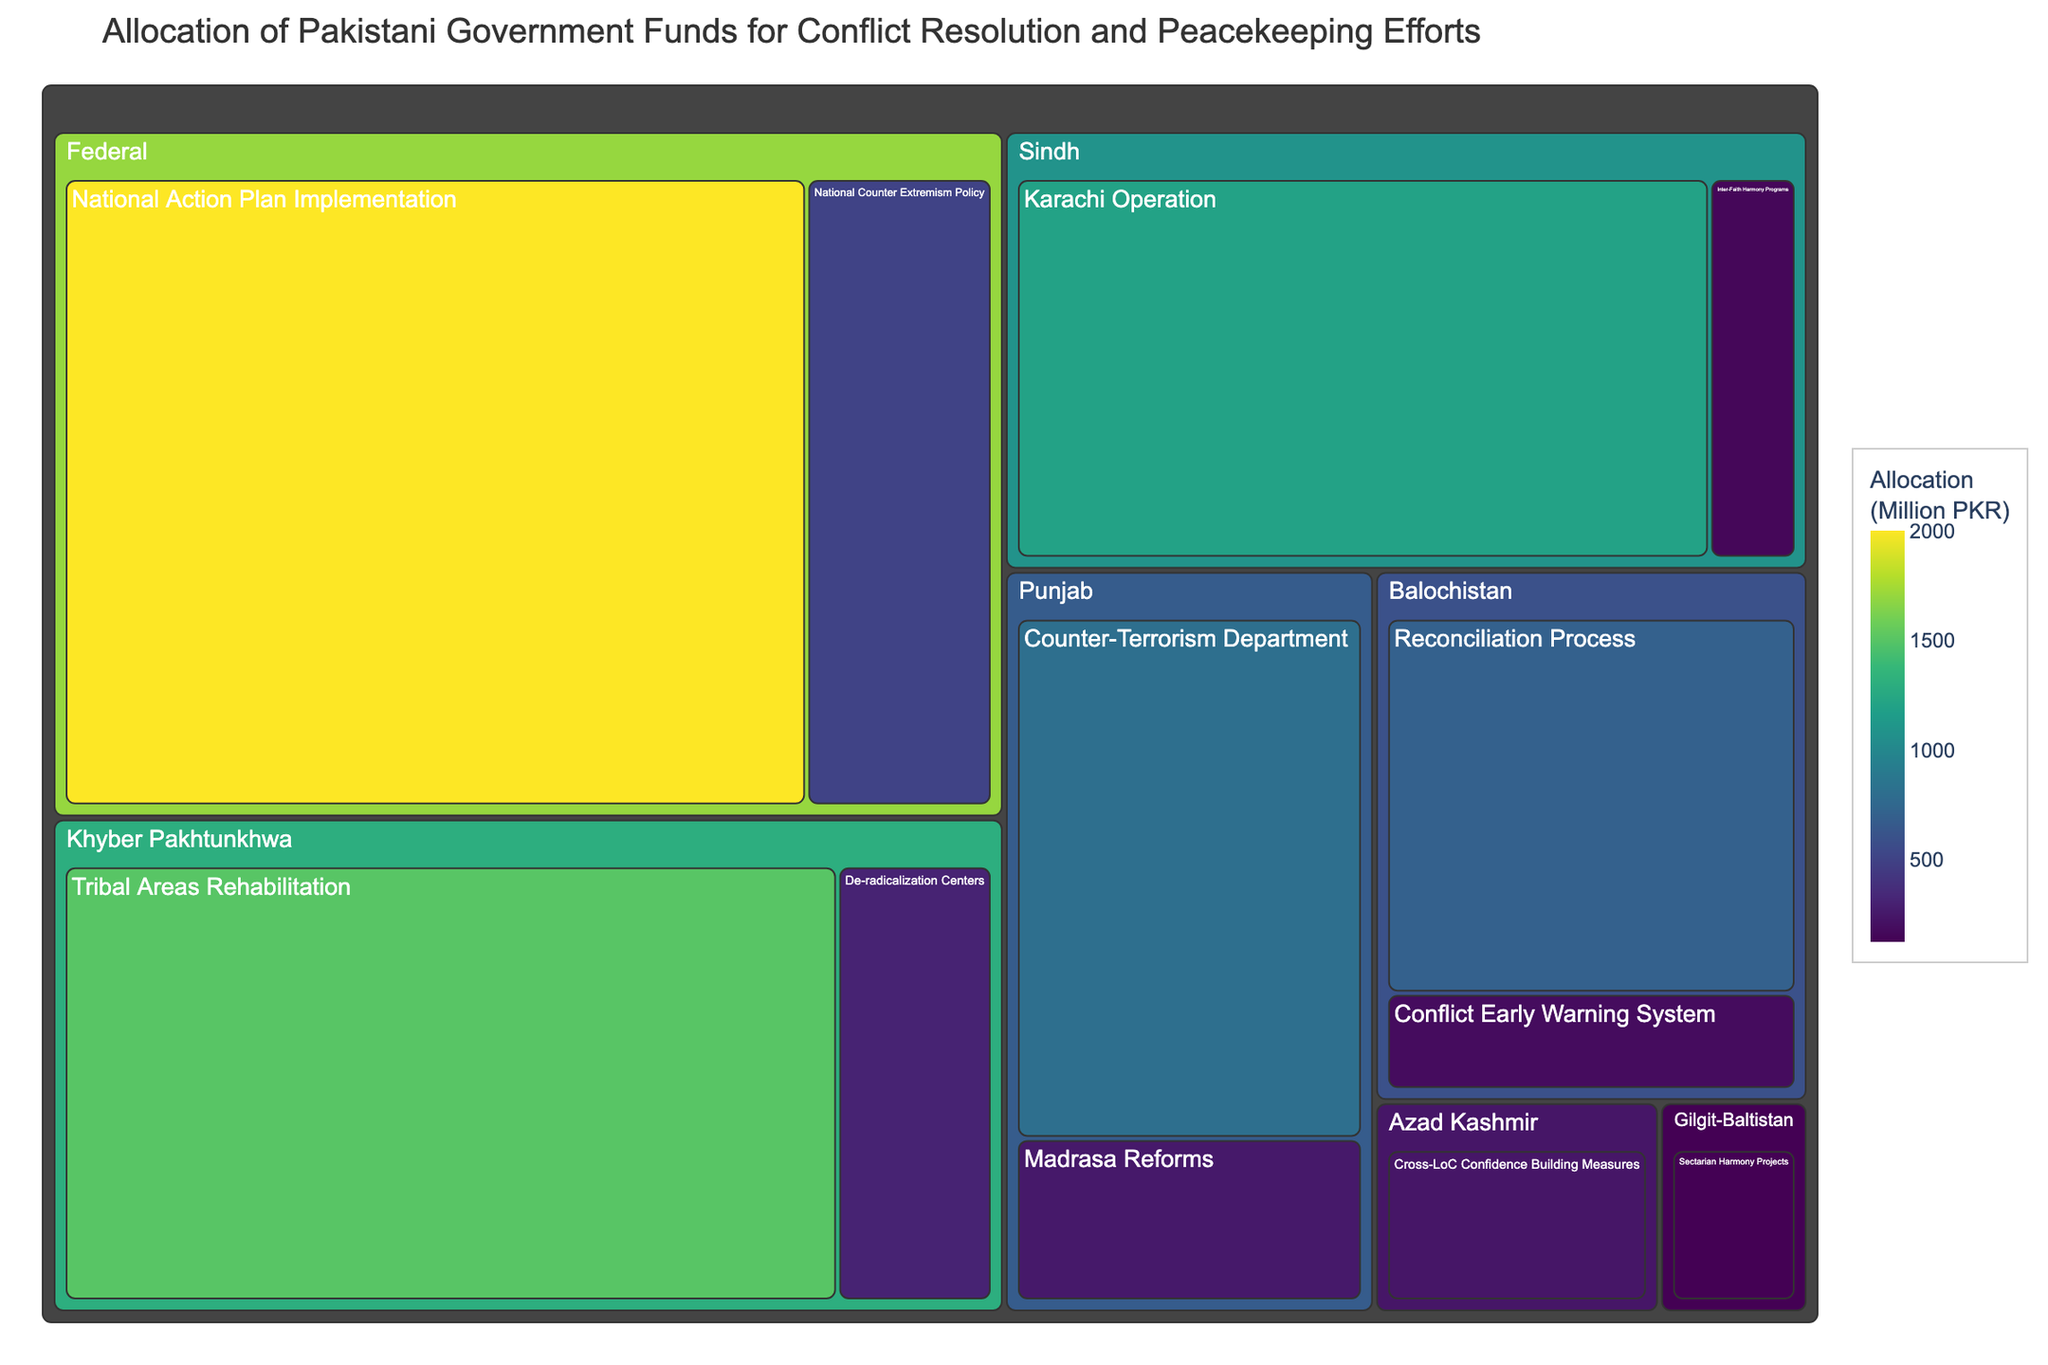What is the title of the treemap? The title of the treemap is often displayed at the top of the figure, providing an overview of what the data visualization represents.
Answer: Allocation of Pakistani Government Funds for Conflict Resolution and Peacekeeping Efforts Which initiative in Khyber Pakhtunkhwa has the lowest allocation? By examining the boxes labeled with initiatives under the Khyber Pakhtunkhwa region, the one with the smallest box will have the lowest allocation.
Answer: De-radicalization Centers What is the sum of allocations for initiatives in Punjab? Add up the allocations for 'Counter-Terrorism Department' and 'Madrasa Reforms' displayed in the Punjab section.
Answer: 1050 Million PKR How much more is allocated to the National Action Plan Implementation compared to the Karachi Operation? Subtract the allocation for 'Karachi Operation' in Sindh from the allocation for 'National Action Plan Implementation' in the Federal region.
Answer: 800 Million PKR Which region received the highest total allocation, and how much was it? By comparing the sum of allocations for each region, identify the region with the highest total allocation.
Answer: Federal, 2500 Million PKR What are the allocations for the two initiatives in Balochistan? Look at the labels under Balochistan and identify the respective allocations for 'Reconciliation Process' and 'Conflict Early Warning System'.
Answer: 700 Million PKR and 180 Million PKR Compare the allocation for Cross-LoC Confidence Building Measures to Sectarian Harmony Projects. Which one received more funding? Compare the allocation amounts listed under Azad Kashmir and Gilgit-Baltistan.
Answer: Cross-LoC Confidence Building Measures What is the average allocation for initiatives in Sindh? Add the allocations for 'Karachi Operation' and 'Inter-Faith Harmony Programs' in Sindh and divide by 2. Detailed calculation steps: (1200 + 150) / 2 = 675.
Answer: 675 Million PKR How is the color scale significant in the treemap? The color scale represents the allocation amount, with different colors signifying various levels of funding, helping to visually distinguish higher and lower allocations.
Answer: Higher allocations are darker; lower allocations are lighter What proportion of the total allocation does the National Action Plan Implementation represent? Sum all allocations, then divide the allocation for 'National Action Plan Implementation' by this total and convert to a percentage. Total allocation is 7930 Million PKR, so (2000 / 7930) x 100 ≈ 25.2%.
Answer: Approximately 25.2% 